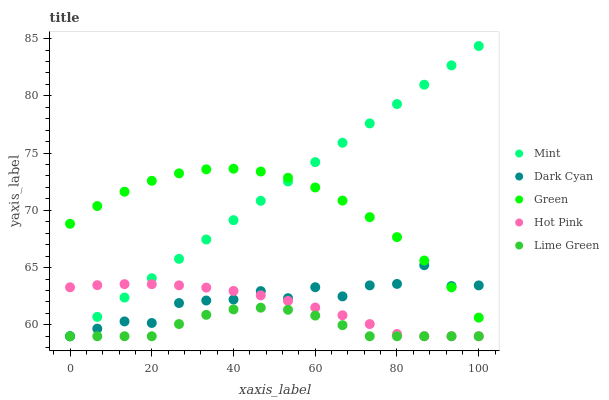Does Lime Green have the minimum area under the curve?
Answer yes or no. Yes. Does Mint have the maximum area under the curve?
Answer yes or no. Yes. Does Green have the minimum area under the curve?
Answer yes or no. No. Does Green have the maximum area under the curve?
Answer yes or no. No. Is Mint the smoothest?
Answer yes or no. Yes. Is Dark Cyan the roughest?
Answer yes or no. Yes. Is Green the smoothest?
Answer yes or no. No. Is Green the roughest?
Answer yes or no. No. Does Dark Cyan have the lowest value?
Answer yes or no. Yes. Does Green have the lowest value?
Answer yes or no. No. Does Mint have the highest value?
Answer yes or no. Yes. Does Green have the highest value?
Answer yes or no. No. Is Hot Pink less than Green?
Answer yes or no. Yes. Is Green greater than Lime Green?
Answer yes or no. Yes. Does Lime Green intersect Mint?
Answer yes or no. Yes. Is Lime Green less than Mint?
Answer yes or no. No. Is Lime Green greater than Mint?
Answer yes or no. No. Does Hot Pink intersect Green?
Answer yes or no. No. 